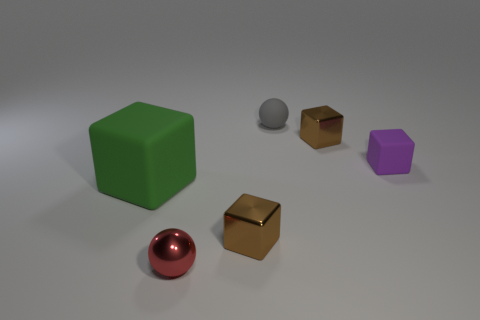Can you describe the shapes and colors of the objects in the image? Certainly! There are six objects in the image, each with a distinct shape and color. Starting from the left, there's a large green cube, a shiny red sphere, a small gray sphere, a small golden cube, a medium-sized purple pentagonal prism, and finally, another small golden cube. The background is neutral, providing a clear contrast for the colorful objects. 